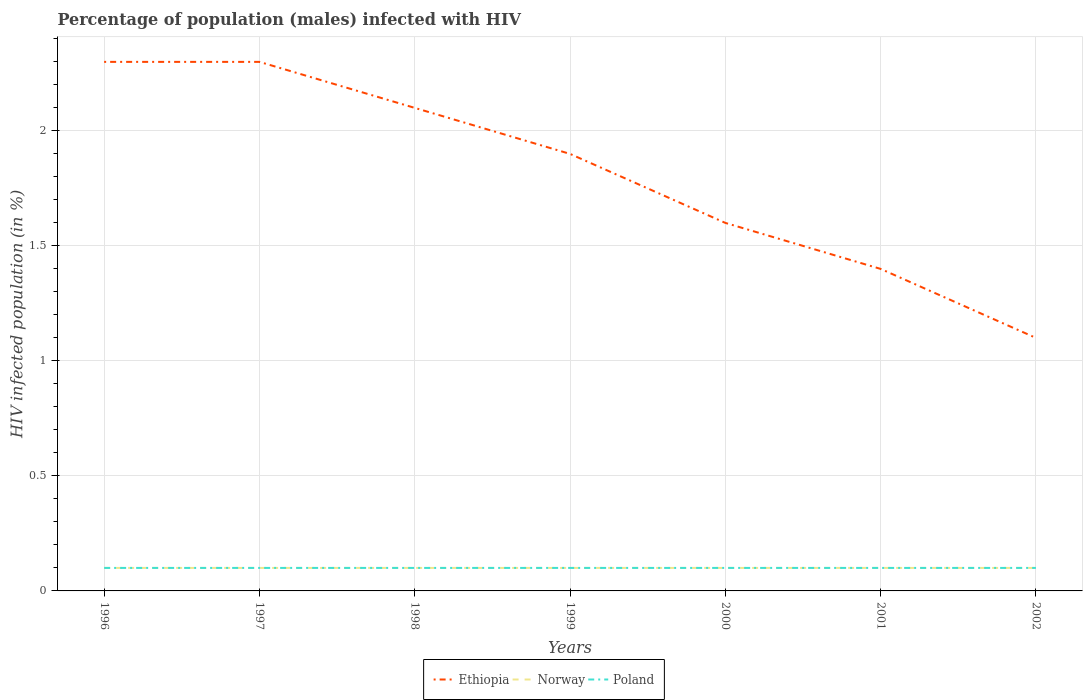What is the difference between the highest and the second highest percentage of HIV infected male population in Norway?
Make the answer very short. 0. How many lines are there?
Keep it short and to the point. 3. Are the values on the major ticks of Y-axis written in scientific E-notation?
Make the answer very short. No. Does the graph contain any zero values?
Offer a very short reply. No. Where does the legend appear in the graph?
Ensure brevity in your answer.  Bottom center. How are the legend labels stacked?
Provide a short and direct response. Horizontal. What is the title of the graph?
Provide a succinct answer. Percentage of population (males) infected with HIV. What is the label or title of the X-axis?
Offer a very short reply. Years. What is the label or title of the Y-axis?
Your answer should be very brief. HIV infected population (in %). What is the HIV infected population (in %) of Ethiopia in 1996?
Give a very brief answer. 2.3. What is the HIV infected population (in %) in Norway in 1996?
Make the answer very short. 0.1. What is the HIV infected population (in %) of Poland in 1996?
Your answer should be compact. 0.1. What is the HIV infected population (in %) of Norway in 1997?
Provide a short and direct response. 0.1. What is the HIV infected population (in %) in Poland in 1997?
Your response must be concise. 0.1. What is the HIV infected population (in %) in Ethiopia in 1998?
Your response must be concise. 2.1. What is the HIV infected population (in %) in Norway in 1998?
Your answer should be compact. 0.1. What is the HIV infected population (in %) in Poland in 1998?
Offer a very short reply. 0.1. What is the HIV infected population (in %) of Poland in 2000?
Keep it short and to the point. 0.1. What is the HIV infected population (in %) in Ethiopia in 2001?
Keep it short and to the point. 1.4. What is the HIV infected population (in %) in Norway in 2001?
Your answer should be compact. 0.1. What is the HIV infected population (in %) of Ethiopia in 2002?
Offer a terse response. 1.1. What is the HIV infected population (in %) in Norway in 2002?
Give a very brief answer. 0.1. Across all years, what is the maximum HIV infected population (in %) in Ethiopia?
Your answer should be compact. 2.3. Across all years, what is the minimum HIV infected population (in %) in Ethiopia?
Provide a succinct answer. 1.1. Across all years, what is the minimum HIV infected population (in %) in Norway?
Provide a short and direct response. 0.1. Across all years, what is the minimum HIV infected population (in %) in Poland?
Your response must be concise. 0.1. What is the total HIV infected population (in %) of Norway in the graph?
Ensure brevity in your answer.  0.7. What is the total HIV infected population (in %) of Poland in the graph?
Ensure brevity in your answer.  0.7. What is the difference between the HIV infected population (in %) of Norway in 1996 and that in 1998?
Your response must be concise. 0. What is the difference between the HIV infected population (in %) of Ethiopia in 1996 and that in 1999?
Offer a very short reply. 0.4. What is the difference between the HIV infected population (in %) of Ethiopia in 1996 and that in 2000?
Ensure brevity in your answer.  0.7. What is the difference between the HIV infected population (in %) in Ethiopia in 1996 and that in 2002?
Keep it short and to the point. 1.2. What is the difference between the HIV infected population (in %) in Poland in 1996 and that in 2002?
Ensure brevity in your answer.  0. What is the difference between the HIV infected population (in %) in Ethiopia in 1997 and that in 1998?
Provide a succinct answer. 0.2. What is the difference between the HIV infected population (in %) of Ethiopia in 1997 and that in 1999?
Your response must be concise. 0.4. What is the difference between the HIV infected population (in %) in Poland in 1997 and that in 1999?
Your response must be concise. 0. What is the difference between the HIV infected population (in %) in Ethiopia in 1997 and that in 2001?
Keep it short and to the point. 0.9. What is the difference between the HIV infected population (in %) in Norway in 1997 and that in 2001?
Provide a short and direct response. 0. What is the difference between the HIV infected population (in %) of Poland in 1997 and that in 2001?
Keep it short and to the point. 0. What is the difference between the HIV infected population (in %) of Norway in 1998 and that in 1999?
Offer a terse response. 0. What is the difference between the HIV infected population (in %) of Norway in 1998 and that in 2000?
Offer a very short reply. 0. What is the difference between the HIV infected population (in %) in Ethiopia in 1998 and that in 2001?
Offer a very short reply. 0.7. What is the difference between the HIV infected population (in %) of Norway in 1998 and that in 2001?
Provide a short and direct response. 0. What is the difference between the HIV infected population (in %) of Poland in 1998 and that in 2001?
Your response must be concise. 0. What is the difference between the HIV infected population (in %) in Ethiopia in 1998 and that in 2002?
Provide a succinct answer. 1. What is the difference between the HIV infected population (in %) of Norway in 1998 and that in 2002?
Provide a succinct answer. 0. What is the difference between the HIV infected population (in %) of Poland in 1998 and that in 2002?
Offer a very short reply. 0. What is the difference between the HIV infected population (in %) in Ethiopia in 1999 and that in 2000?
Make the answer very short. 0.3. What is the difference between the HIV infected population (in %) of Norway in 1999 and that in 2001?
Your answer should be compact. 0. What is the difference between the HIV infected population (in %) in Poland in 1999 and that in 2002?
Your response must be concise. 0. What is the difference between the HIV infected population (in %) in Ethiopia in 2000 and that in 2001?
Your answer should be compact. 0.2. What is the difference between the HIV infected population (in %) of Poland in 2000 and that in 2001?
Offer a terse response. 0. What is the difference between the HIV infected population (in %) of Norway in 2000 and that in 2002?
Provide a succinct answer. 0. What is the difference between the HIV infected population (in %) in Ethiopia in 2001 and that in 2002?
Provide a short and direct response. 0.3. What is the difference between the HIV infected population (in %) of Ethiopia in 1996 and the HIV infected population (in %) of Norway in 1997?
Give a very brief answer. 2.2. What is the difference between the HIV infected population (in %) in Norway in 1996 and the HIV infected population (in %) in Poland in 1997?
Provide a succinct answer. 0. What is the difference between the HIV infected population (in %) in Ethiopia in 1996 and the HIV infected population (in %) in Norway in 1998?
Offer a terse response. 2.2. What is the difference between the HIV infected population (in %) of Ethiopia in 1996 and the HIV infected population (in %) of Poland in 1998?
Provide a short and direct response. 2.2. What is the difference between the HIV infected population (in %) of Norway in 1996 and the HIV infected population (in %) of Poland in 1998?
Your answer should be very brief. 0. What is the difference between the HIV infected population (in %) of Ethiopia in 1996 and the HIV infected population (in %) of Poland in 1999?
Keep it short and to the point. 2.2. What is the difference between the HIV infected population (in %) in Norway in 1996 and the HIV infected population (in %) in Poland in 1999?
Ensure brevity in your answer.  0. What is the difference between the HIV infected population (in %) in Ethiopia in 1996 and the HIV infected population (in %) in Poland in 2000?
Your answer should be very brief. 2.2. What is the difference between the HIV infected population (in %) in Ethiopia in 1996 and the HIV infected population (in %) in Norway in 2001?
Ensure brevity in your answer.  2.2. What is the difference between the HIV infected population (in %) in Norway in 1996 and the HIV infected population (in %) in Poland in 2001?
Provide a succinct answer. 0. What is the difference between the HIV infected population (in %) of Norway in 1996 and the HIV infected population (in %) of Poland in 2002?
Provide a short and direct response. 0. What is the difference between the HIV infected population (in %) in Norway in 1997 and the HIV infected population (in %) in Poland in 1998?
Make the answer very short. 0. What is the difference between the HIV infected population (in %) of Ethiopia in 1997 and the HIV infected population (in %) of Norway in 1999?
Your answer should be compact. 2.2. What is the difference between the HIV infected population (in %) of Ethiopia in 1997 and the HIV infected population (in %) of Norway in 2000?
Offer a very short reply. 2.2. What is the difference between the HIV infected population (in %) in Ethiopia in 1997 and the HIV infected population (in %) in Poland in 2000?
Your answer should be very brief. 2.2. What is the difference between the HIV infected population (in %) in Ethiopia in 1997 and the HIV infected population (in %) in Norway in 2001?
Your response must be concise. 2.2. What is the difference between the HIV infected population (in %) of Ethiopia in 1997 and the HIV infected population (in %) of Poland in 2001?
Make the answer very short. 2.2. What is the difference between the HIV infected population (in %) in Norway in 1997 and the HIV infected population (in %) in Poland in 2001?
Provide a succinct answer. 0. What is the difference between the HIV infected population (in %) in Ethiopia in 1997 and the HIV infected population (in %) in Poland in 2002?
Your answer should be very brief. 2.2. What is the difference between the HIV infected population (in %) in Ethiopia in 1998 and the HIV infected population (in %) in Norway in 1999?
Your answer should be compact. 2. What is the difference between the HIV infected population (in %) in Norway in 1998 and the HIV infected population (in %) in Poland in 1999?
Your answer should be compact. 0. What is the difference between the HIV infected population (in %) in Ethiopia in 1998 and the HIV infected population (in %) in Norway in 2001?
Your response must be concise. 2. What is the difference between the HIV infected population (in %) in Norway in 1998 and the HIV infected population (in %) in Poland in 2001?
Give a very brief answer. 0. What is the difference between the HIV infected population (in %) of Ethiopia in 1998 and the HIV infected population (in %) of Norway in 2002?
Your answer should be very brief. 2. What is the difference between the HIV infected population (in %) in Ethiopia in 1998 and the HIV infected population (in %) in Poland in 2002?
Give a very brief answer. 2. What is the difference between the HIV infected population (in %) of Ethiopia in 1999 and the HIV infected population (in %) of Norway in 2000?
Your answer should be compact. 1.8. What is the difference between the HIV infected population (in %) of Ethiopia in 1999 and the HIV infected population (in %) of Poland in 2001?
Keep it short and to the point. 1.8. What is the difference between the HIV infected population (in %) in Norway in 1999 and the HIV infected population (in %) in Poland in 2001?
Make the answer very short. 0. What is the difference between the HIV infected population (in %) of Ethiopia in 1999 and the HIV infected population (in %) of Norway in 2002?
Make the answer very short. 1.8. What is the difference between the HIV infected population (in %) in Ethiopia in 1999 and the HIV infected population (in %) in Poland in 2002?
Offer a very short reply. 1.8. What is the difference between the HIV infected population (in %) in Ethiopia in 2000 and the HIV infected population (in %) in Norway in 2001?
Your answer should be compact. 1.5. What is the difference between the HIV infected population (in %) in Norway in 2000 and the HIV infected population (in %) in Poland in 2002?
Give a very brief answer. 0. What is the average HIV infected population (in %) of Ethiopia per year?
Offer a very short reply. 1.81. What is the average HIV infected population (in %) of Norway per year?
Your response must be concise. 0.1. What is the average HIV infected population (in %) of Poland per year?
Your answer should be very brief. 0.1. In the year 1996, what is the difference between the HIV infected population (in %) in Ethiopia and HIV infected population (in %) in Norway?
Offer a terse response. 2.2. In the year 1996, what is the difference between the HIV infected population (in %) in Ethiopia and HIV infected population (in %) in Poland?
Your answer should be very brief. 2.2. In the year 1996, what is the difference between the HIV infected population (in %) in Norway and HIV infected population (in %) in Poland?
Ensure brevity in your answer.  0. In the year 1998, what is the difference between the HIV infected population (in %) in Ethiopia and HIV infected population (in %) in Poland?
Your answer should be very brief. 2. In the year 1998, what is the difference between the HIV infected population (in %) in Norway and HIV infected population (in %) in Poland?
Offer a terse response. 0. In the year 1999, what is the difference between the HIV infected population (in %) of Ethiopia and HIV infected population (in %) of Poland?
Your answer should be very brief. 1.8. In the year 2000, what is the difference between the HIV infected population (in %) in Ethiopia and HIV infected population (in %) in Norway?
Make the answer very short. 1.5. In the year 2000, what is the difference between the HIV infected population (in %) in Ethiopia and HIV infected population (in %) in Poland?
Keep it short and to the point. 1.5. In the year 2000, what is the difference between the HIV infected population (in %) of Norway and HIV infected population (in %) of Poland?
Ensure brevity in your answer.  0. In the year 2001, what is the difference between the HIV infected population (in %) of Norway and HIV infected population (in %) of Poland?
Give a very brief answer. 0. In the year 2002, what is the difference between the HIV infected population (in %) in Ethiopia and HIV infected population (in %) in Norway?
Offer a terse response. 1. In the year 2002, what is the difference between the HIV infected population (in %) of Norway and HIV infected population (in %) of Poland?
Ensure brevity in your answer.  0. What is the ratio of the HIV infected population (in %) in Poland in 1996 to that in 1997?
Provide a succinct answer. 1. What is the ratio of the HIV infected population (in %) in Ethiopia in 1996 to that in 1998?
Provide a succinct answer. 1.1. What is the ratio of the HIV infected population (in %) of Ethiopia in 1996 to that in 1999?
Provide a succinct answer. 1.21. What is the ratio of the HIV infected population (in %) in Norway in 1996 to that in 1999?
Keep it short and to the point. 1. What is the ratio of the HIV infected population (in %) in Ethiopia in 1996 to that in 2000?
Ensure brevity in your answer.  1.44. What is the ratio of the HIV infected population (in %) in Norway in 1996 to that in 2000?
Your answer should be very brief. 1. What is the ratio of the HIV infected population (in %) of Ethiopia in 1996 to that in 2001?
Your answer should be very brief. 1.64. What is the ratio of the HIV infected population (in %) of Ethiopia in 1996 to that in 2002?
Your answer should be very brief. 2.09. What is the ratio of the HIV infected population (in %) in Norway in 1996 to that in 2002?
Offer a very short reply. 1. What is the ratio of the HIV infected population (in %) of Ethiopia in 1997 to that in 1998?
Provide a succinct answer. 1.1. What is the ratio of the HIV infected population (in %) of Norway in 1997 to that in 1998?
Offer a very short reply. 1. What is the ratio of the HIV infected population (in %) of Poland in 1997 to that in 1998?
Provide a short and direct response. 1. What is the ratio of the HIV infected population (in %) of Ethiopia in 1997 to that in 1999?
Make the answer very short. 1.21. What is the ratio of the HIV infected population (in %) in Norway in 1997 to that in 1999?
Offer a terse response. 1. What is the ratio of the HIV infected population (in %) of Ethiopia in 1997 to that in 2000?
Provide a short and direct response. 1.44. What is the ratio of the HIV infected population (in %) in Ethiopia in 1997 to that in 2001?
Provide a short and direct response. 1.64. What is the ratio of the HIV infected population (in %) in Ethiopia in 1997 to that in 2002?
Your answer should be compact. 2.09. What is the ratio of the HIV infected population (in %) of Norway in 1997 to that in 2002?
Provide a short and direct response. 1. What is the ratio of the HIV infected population (in %) of Ethiopia in 1998 to that in 1999?
Offer a very short reply. 1.11. What is the ratio of the HIV infected population (in %) in Norway in 1998 to that in 1999?
Keep it short and to the point. 1. What is the ratio of the HIV infected population (in %) of Ethiopia in 1998 to that in 2000?
Offer a terse response. 1.31. What is the ratio of the HIV infected population (in %) in Norway in 1998 to that in 2000?
Ensure brevity in your answer.  1. What is the ratio of the HIV infected population (in %) of Poland in 1998 to that in 2000?
Your answer should be compact. 1. What is the ratio of the HIV infected population (in %) in Ethiopia in 1998 to that in 2001?
Make the answer very short. 1.5. What is the ratio of the HIV infected population (in %) in Poland in 1998 to that in 2001?
Your answer should be compact. 1. What is the ratio of the HIV infected population (in %) of Ethiopia in 1998 to that in 2002?
Your response must be concise. 1.91. What is the ratio of the HIV infected population (in %) in Ethiopia in 1999 to that in 2000?
Your answer should be compact. 1.19. What is the ratio of the HIV infected population (in %) in Norway in 1999 to that in 2000?
Your answer should be very brief. 1. What is the ratio of the HIV infected population (in %) in Ethiopia in 1999 to that in 2001?
Provide a succinct answer. 1.36. What is the ratio of the HIV infected population (in %) of Ethiopia in 1999 to that in 2002?
Offer a terse response. 1.73. What is the ratio of the HIV infected population (in %) in Norway in 1999 to that in 2002?
Your answer should be very brief. 1. What is the ratio of the HIV infected population (in %) in Poland in 1999 to that in 2002?
Give a very brief answer. 1. What is the ratio of the HIV infected population (in %) of Ethiopia in 2000 to that in 2002?
Provide a succinct answer. 1.45. What is the ratio of the HIV infected population (in %) in Norway in 2000 to that in 2002?
Ensure brevity in your answer.  1. What is the ratio of the HIV infected population (in %) of Ethiopia in 2001 to that in 2002?
Offer a very short reply. 1.27. What is the ratio of the HIV infected population (in %) of Norway in 2001 to that in 2002?
Your answer should be very brief. 1. What is the ratio of the HIV infected population (in %) of Poland in 2001 to that in 2002?
Provide a succinct answer. 1. What is the difference between the highest and the lowest HIV infected population (in %) of Ethiopia?
Your answer should be compact. 1.2. What is the difference between the highest and the lowest HIV infected population (in %) of Poland?
Your response must be concise. 0. 